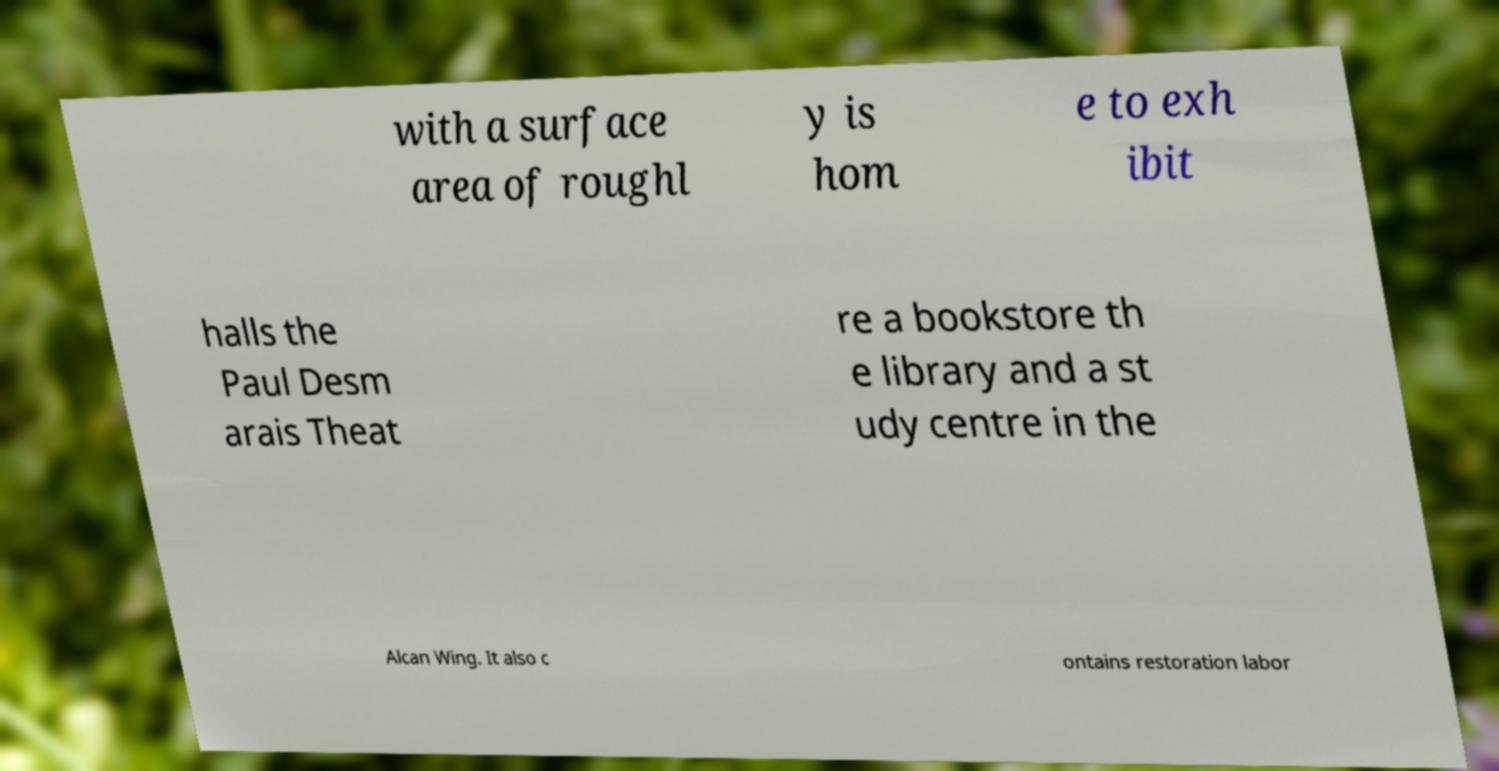What messages or text are displayed in this image? I need them in a readable, typed format. with a surface area of roughl y is hom e to exh ibit halls the Paul Desm arais Theat re a bookstore th e library and a st udy centre in the Alcan Wing. It also c ontains restoration labor 